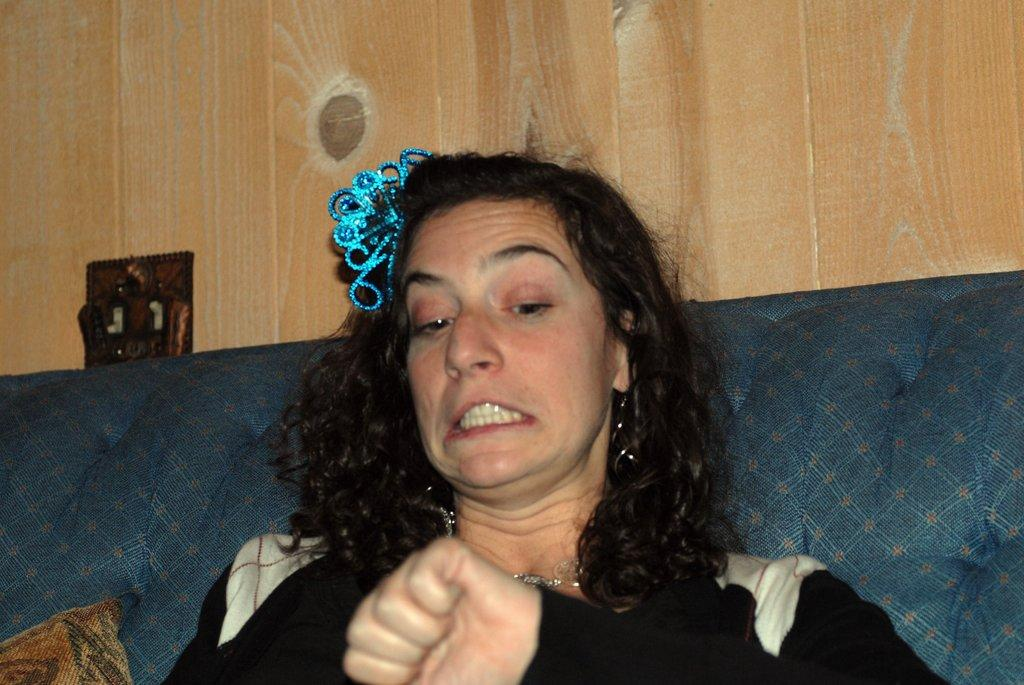What is the woman doing in the image? The woman is sitting on a sofa in the image. What can be seen on the sofa with the woman? There is a pillow in the image. What type of wall is visible in the image? There is a wooden wall in the image. Can you describe the unspecified object in the image? Unfortunately, the facts provided do not give enough information to describe the unspecified object in the image. What type of beetle can be seen crawling on the woman's shoulder in the image? There is no beetle present on the woman's shoulder in the image. 